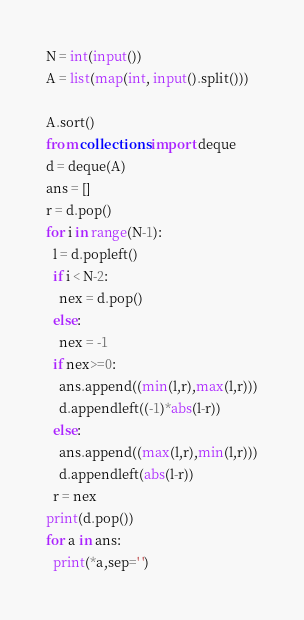<code> <loc_0><loc_0><loc_500><loc_500><_Python_>N = int(input())
A = list(map(int, input().split()))

A.sort()
from collections import deque
d = deque(A)
ans = []
r = d.pop()
for i in range(N-1):
  l = d.popleft()
  if i < N-2:
    nex = d.pop()
  else:
    nex = -1
  if nex>=0:
    ans.append((min(l,r),max(l,r)))
    d.appendleft((-1)*abs(l-r))
  else:
    ans.append((max(l,r),min(l,r)))
    d.appendleft(abs(l-r))
  r = nex
print(d.pop())
for a in ans:
  print(*a,sep=' ')</code> 